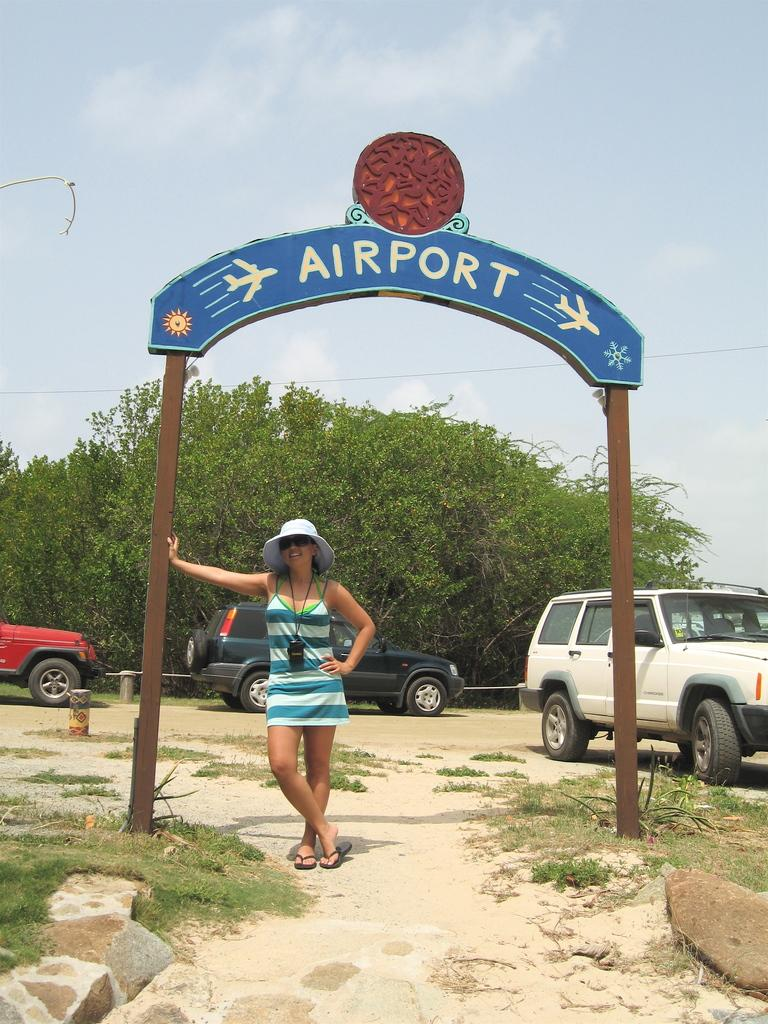What is the main subject in the image? There is a woman standing in the image. What type of terrain is visible in the image? There is grass, rocks, and trees in the image. What else can be seen in the image besides the woman and the terrain? There are vehicles and a board with poles in the image. What is visible in the background of the image? The sky is visible in the background of the image. What type of crown is the woman wearing in the image? There is no crown visible in the image; the woman is not wearing any headwear. How many roses can be seen in the image? There are no roses present in the image. 